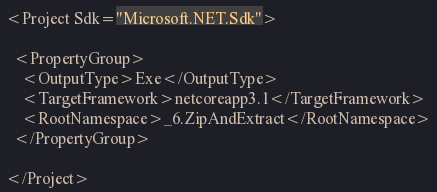Convert code to text. <code><loc_0><loc_0><loc_500><loc_500><_XML_><Project Sdk="Microsoft.NET.Sdk">

  <PropertyGroup>
    <OutputType>Exe</OutputType>
    <TargetFramework>netcoreapp3.1</TargetFramework>
    <RootNamespace>_6.ZipAndExtract</RootNamespace>
  </PropertyGroup>

</Project>
</code> 